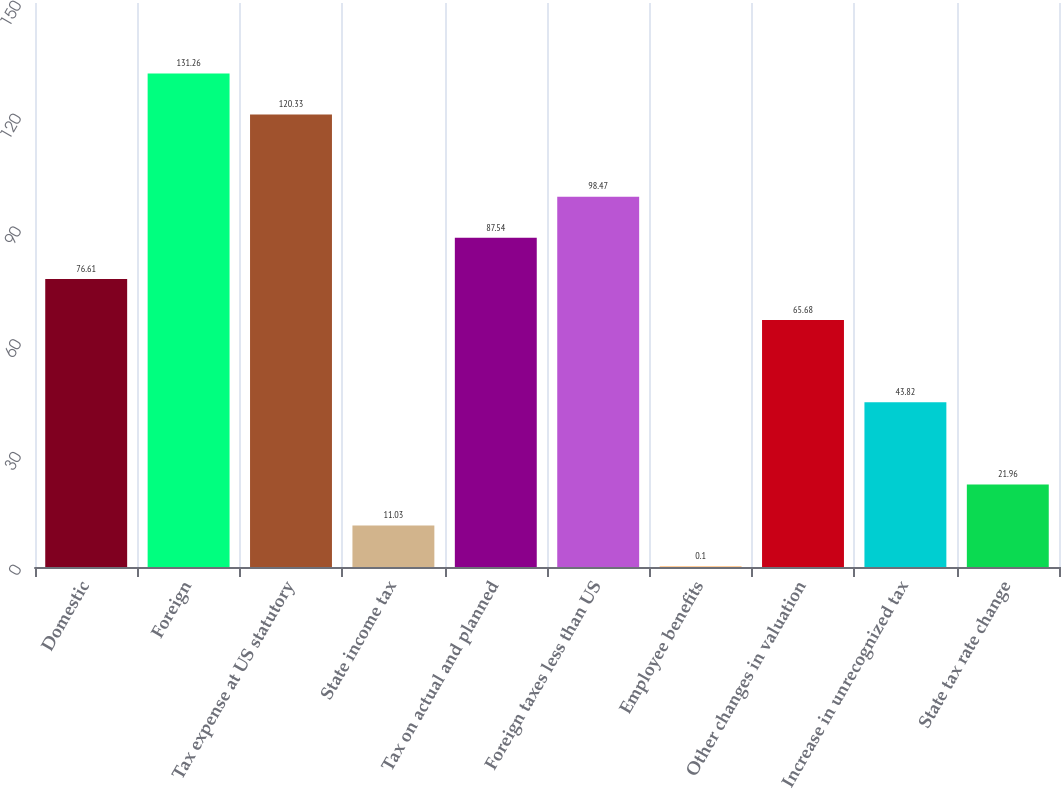Convert chart. <chart><loc_0><loc_0><loc_500><loc_500><bar_chart><fcel>Domestic<fcel>Foreign<fcel>Tax expense at US statutory<fcel>State income tax<fcel>Tax on actual and planned<fcel>Foreign taxes less than US<fcel>Employee benefits<fcel>Other changes in valuation<fcel>Increase in unrecognized tax<fcel>State tax rate change<nl><fcel>76.61<fcel>131.26<fcel>120.33<fcel>11.03<fcel>87.54<fcel>98.47<fcel>0.1<fcel>65.68<fcel>43.82<fcel>21.96<nl></chart> 